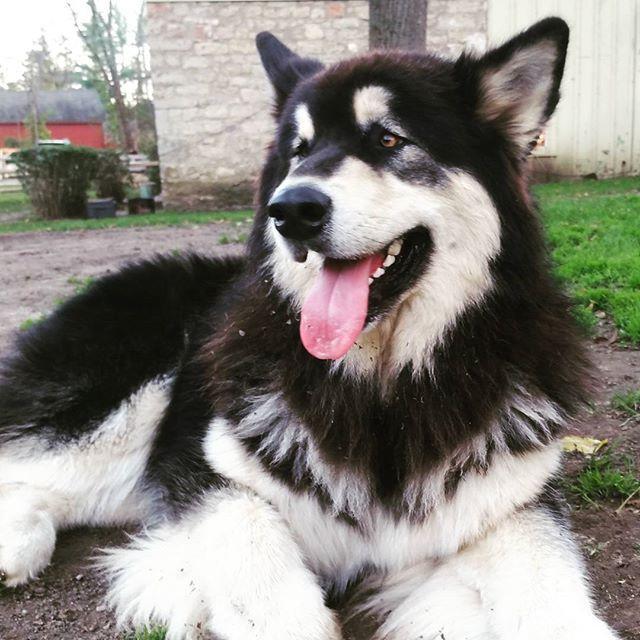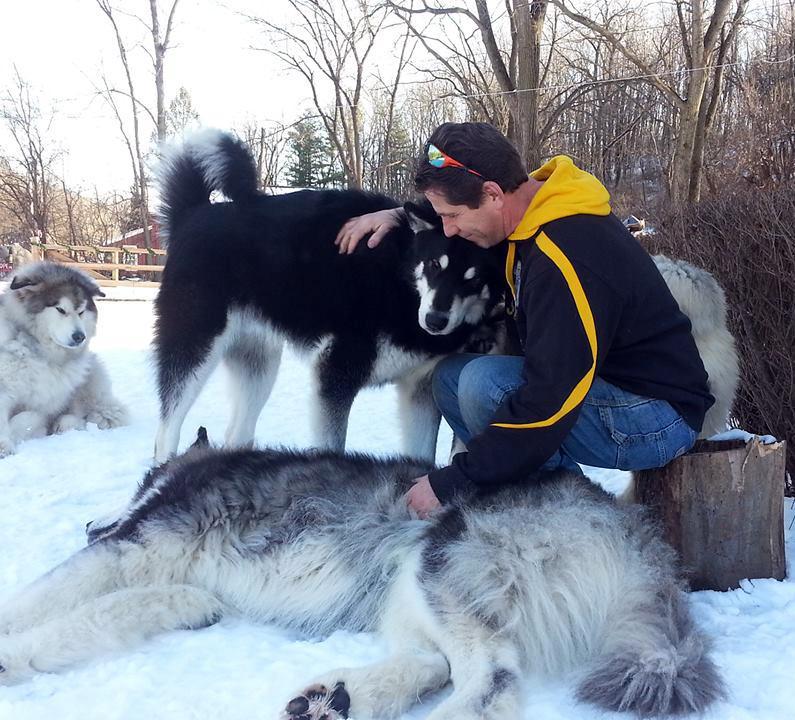The first image is the image on the left, the second image is the image on the right. Assess this claim about the two images: "A person wearing black is beside a black-and-white husky in the left image, and the right image shows a reclining dog with white and brown fur.". Correct or not? Answer yes or no. No. The first image is the image on the left, the second image is the image on the right. Examine the images to the left and right. Is the description "The dog in the image on the left is standing up outside." accurate? Answer yes or no. No. 